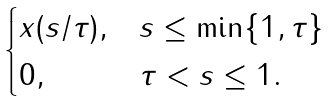<formula> <loc_0><loc_0><loc_500><loc_500>\begin{cases} x ( s / \tau ) , & s \leq \min \{ 1 , \tau \} \\ 0 , & \tau < s \leq 1 . \end{cases}</formula> 